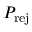<formula> <loc_0><loc_0><loc_500><loc_500>P _ { r e j }</formula> 